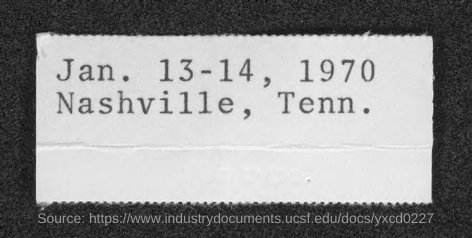What is the date in the document?
Keep it short and to the point. Jan. 13-14, 1970. What is the location in the document?
Offer a very short reply. Nashville, Tenn. 